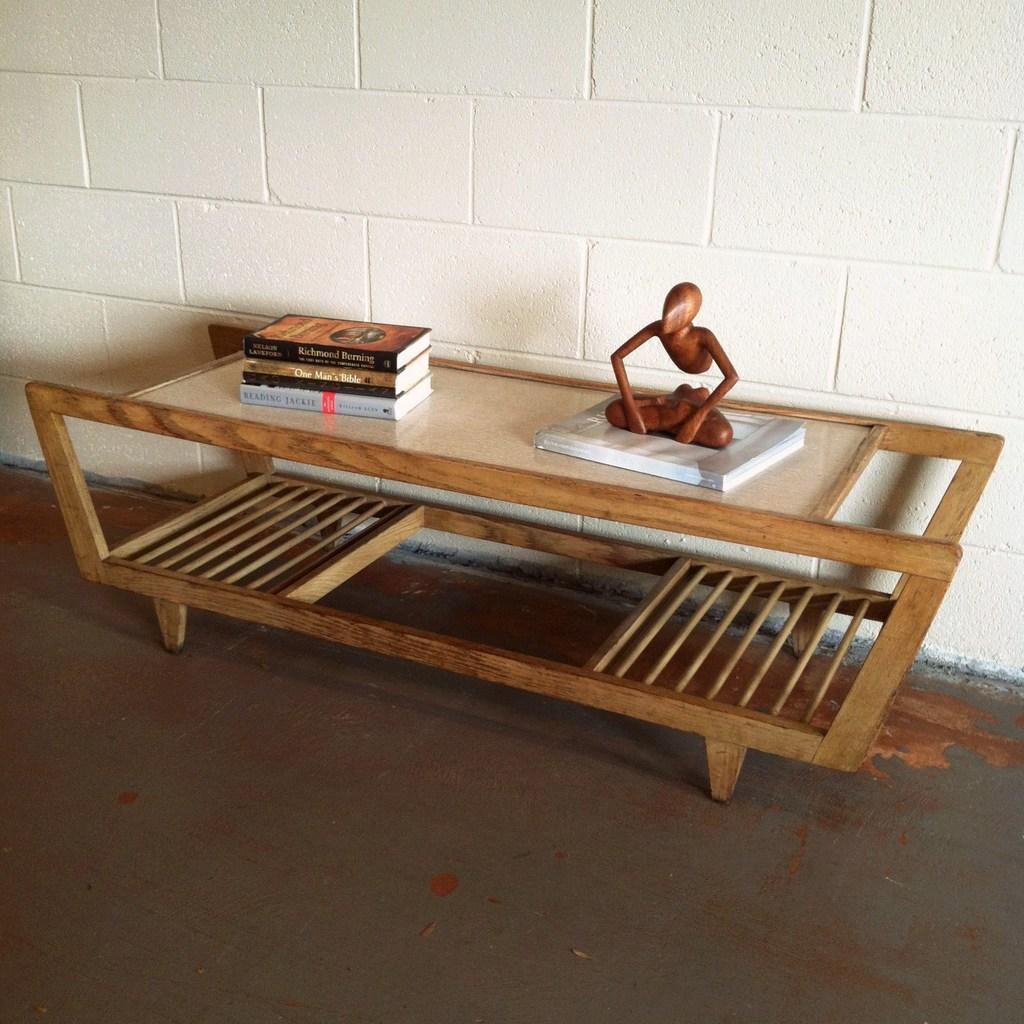Please provide a concise description of this image. This picture shows a table and couple of books on it and a toy 